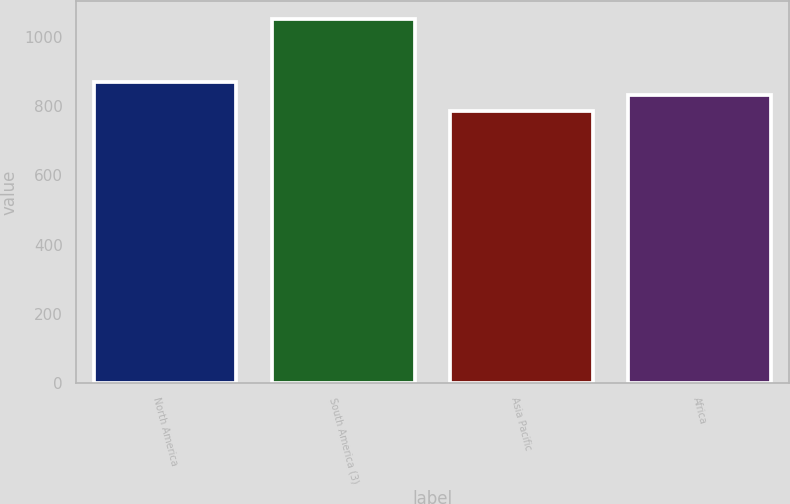Convert chart to OTSL. <chart><loc_0><loc_0><loc_500><loc_500><bar_chart><fcel>North America<fcel>South America (3)<fcel>Asia Pacific<fcel>Africa<nl><fcel>869<fcel>1052<fcel>786<fcel>833<nl></chart> 